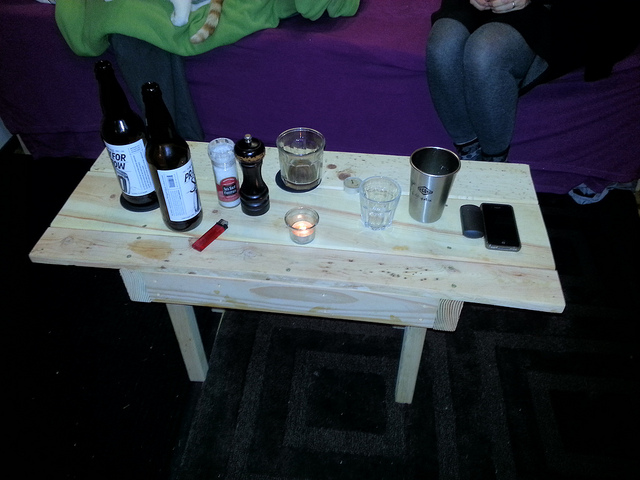What items are on the table aside from the bottles? Aside from the bottles, there is a cylinder-shaped container, possibly a thermos, a glass cup, a tea light candle, a lighter, and a smartphone. 